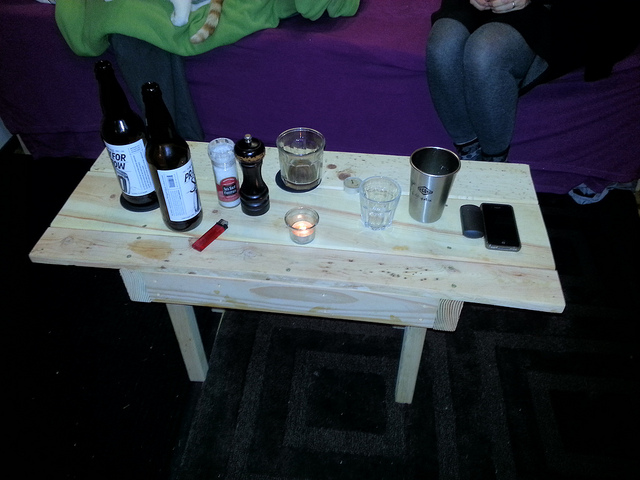What items are on the table aside from the bottles? Aside from the bottles, there is a cylinder-shaped container, possibly a thermos, a glass cup, a tea light candle, a lighter, and a smartphone. 